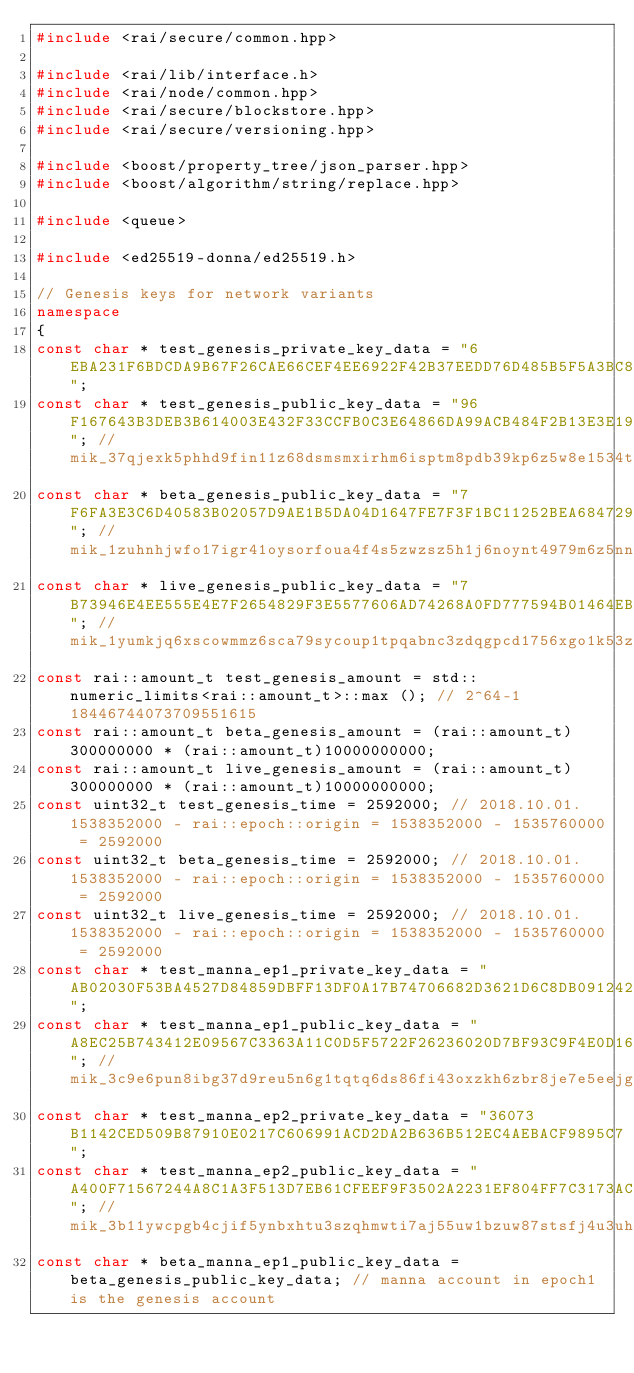<code> <loc_0><loc_0><loc_500><loc_500><_C++_>#include <rai/secure/common.hpp>

#include <rai/lib/interface.h>
#include <rai/node/common.hpp>
#include <rai/secure/blockstore.hpp>
#include <rai/secure/versioning.hpp>

#include <boost/property_tree/json_parser.hpp>
#include <boost/algorithm/string/replace.hpp>

#include <queue>

#include <ed25519-donna/ed25519.h>

// Genesis keys for network variants
namespace
{
const char * test_genesis_private_key_data = "6EBA231F6BDCDA9B67F26CAE66CEF4EE6922F42B37EEDD76D485B5F5A3BC8AA9";
const char * test_genesis_public_key_data = "96F167643B3DEB3B614003E432F33CCFB0C3E64866DA99ACB484F2B13E3E1980"; // mik_37qjexk5phhd9fin11z68dsmsmxirhm6isptm8pdb39kp6z5w8e1534tigqk
const char * beta_genesis_public_key_data = "7F6FA3E3C6D40583B02057D9AE1B5DA04D1647FE7F3F1BC11252BEA684729E64"; // mik_1zuhnhjwfo17igr41oysorfoua4f4s5zwzsz5h1j6noynt4979m6z5nnt5q4
const char * live_genesis_public_key_data = "7B73946E4EE555E4E7F2654829F3E5577606AD74268A0FD777594B01464EBAA0"; // mik_1yumkjq6xscowmmz6sca79sycoup1tpqabnc3zdqgpcd1756xgo1k53z7yeg
const rai::amount_t test_genesis_amount = std::numeric_limits<rai::amount_t>::max (); // 2^64-1 18446744073709551615
const rai::amount_t beta_genesis_amount = (rai::amount_t)300000000 * (rai::amount_t)10000000000;
const rai::amount_t live_genesis_amount = (rai::amount_t)300000000 * (rai::amount_t)10000000000;
const uint32_t test_genesis_time = 2592000; // 2018.10.01.  1538352000 - rai::epoch::origin = 1538352000 - 1535760000 = 2592000
const uint32_t beta_genesis_time = 2592000; // 2018.10.01.  1538352000 - rai::epoch::origin = 1538352000 - 1535760000 = 2592000
const uint32_t live_genesis_time = 2592000; // 2018.10.01.  1538352000 - rai::epoch::origin = 1538352000 - 1535760000 = 2592000
const char * test_manna_ep1_private_key_data = "AB02030F53BA4527D84859DBFF13DF0A17B74706682D3621D6C8DB0912424D3D";
const char * test_manna_ep1_public_key_data = "A8EC25B743412E09567C3363A11C0D5F5722F26236020D7BF93C9F4E0D161583"; // mik_3c9e6pun8ibg37d9reu5n6g1tqtq6ds86fi43oxzkh6zbr8je7e5eejg5r9a
const char * test_manna_ep2_private_key_data = "36073B1142CED509B87910E0217C606991ACD2DA2B636B512EC4AEBACF9895C7";
const char * test_manna_ep2_public_key_data = "A400F71567244A8C1A3F513D7EB61CFEEF9F3502A2231EF804FF7C3173ACB622"; // mik_3b11ywcpgb4cjif5ynbxhtu3szqhmwti7aj55uw1bzuw87stsfj4u3uh955w
const char * beta_manna_ep1_public_key_data = beta_genesis_public_key_data; // manna account in epoch1 is the genesis account</code> 